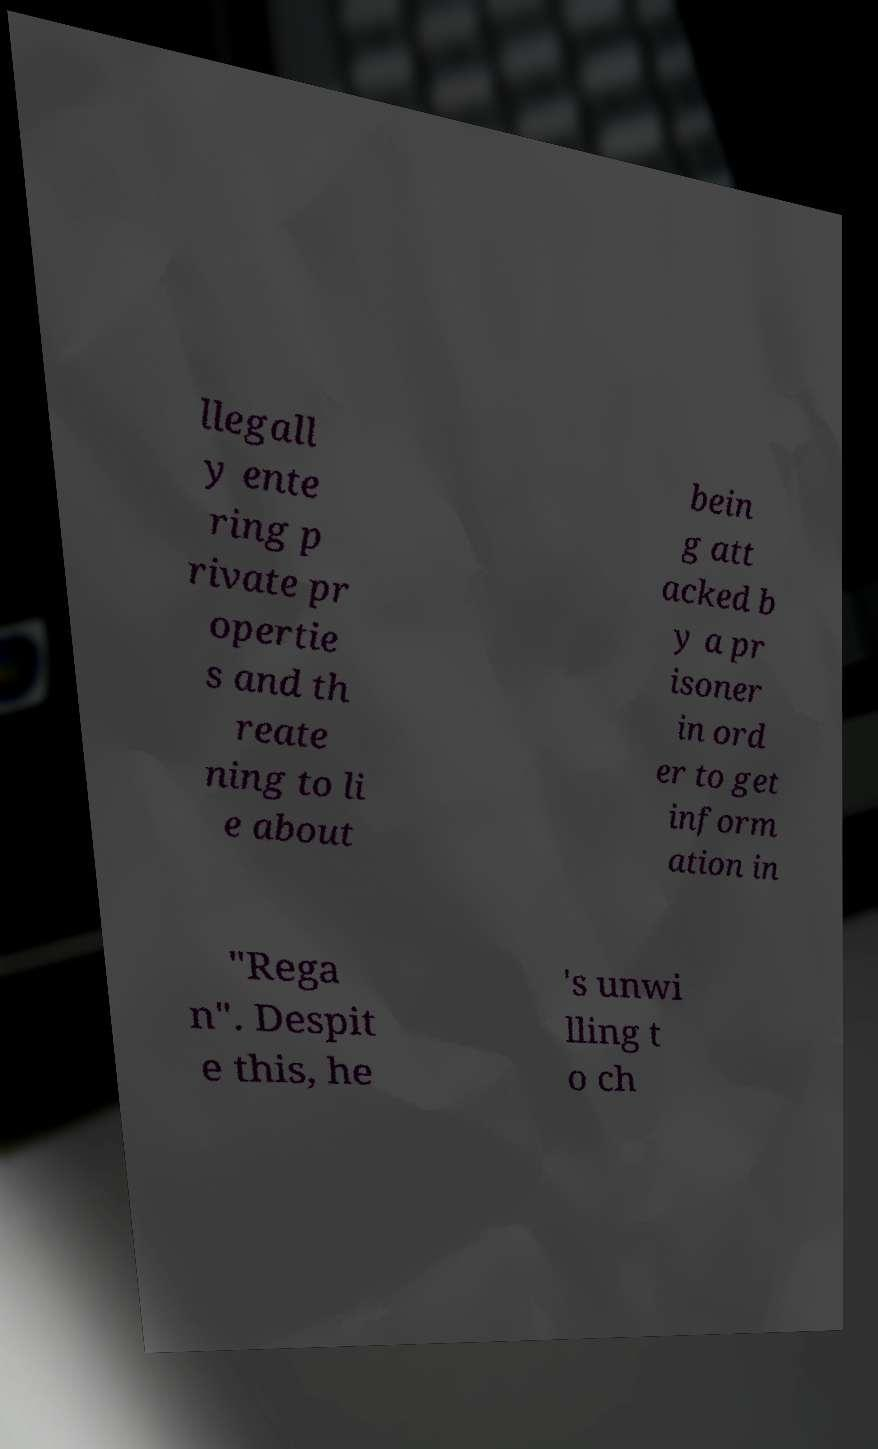Could you extract and type out the text from this image? llegall y ente ring p rivate pr opertie s and th reate ning to li e about bein g att acked b y a pr isoner in ord er to get inform ation in "Rega n". Despit e this, he 's unwi lling t o ch 